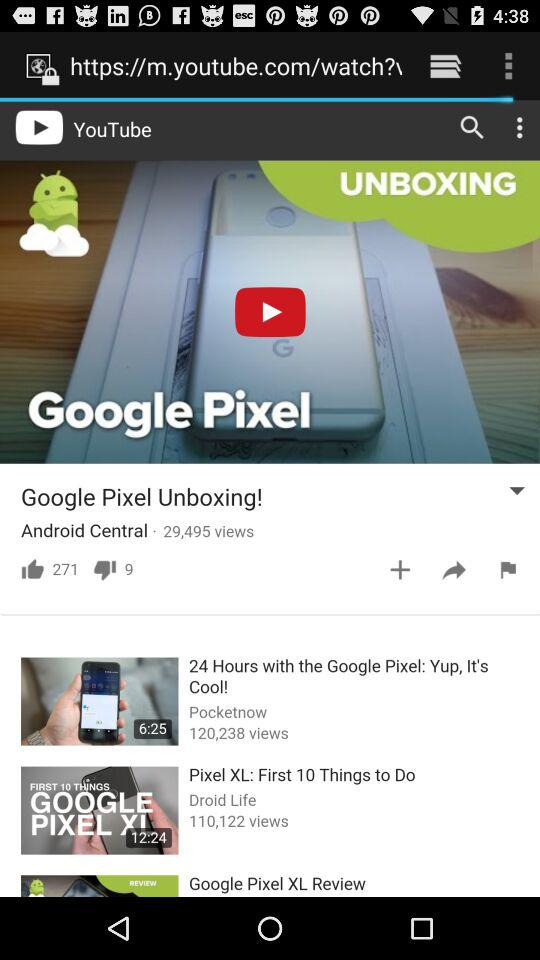How long is the "Google Pixel Unboxing!" video?
When the provided information is insufficient, respond with <no answer>. <no answer> 